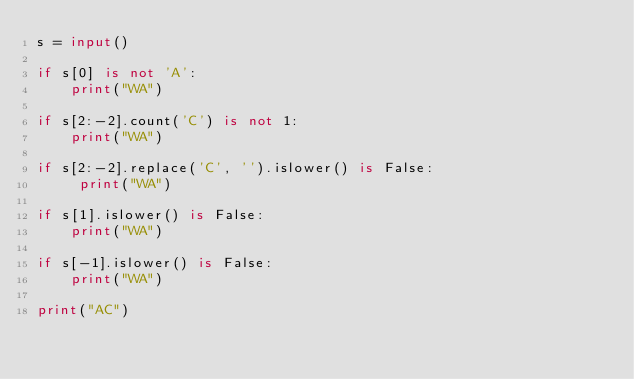Convert code to text. <code><loc_0><loc_0><loc_500><loc_500><_Python_>s = input()

if s[0] is not 'A':
    print("WA")

if s[2:-2].count('C') is not 1:
    print("WA")

if s[2:-2].replace('C', '').islower() is False:
     print("WA")

if s[1].islower() is False:
    print("WA")

if s[-1].islower() is False:
    print("WA")

print("AC")



</code> 